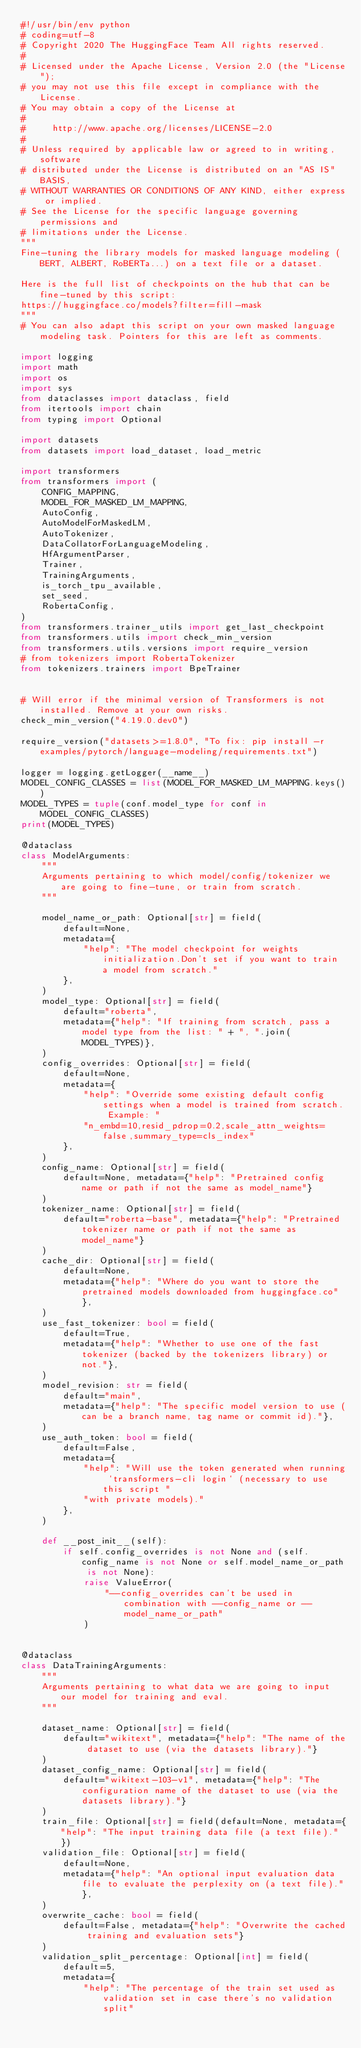Convert code to text. <code><loc_0><loc_0><loc_500><loc_500><_Python_>#!/usr/bin/env python
# coding=utf-8
# Copyright 2020 The HuggingFace Team All rights reserved.
#
# Licensed under the Apache License, Version 2.0 (the "License");
# you may not use this file except in compliance with the License.
# You may obtain a copy of the License at
#
#     http://www.apache.org/licenses/LICENSE-2.0
#
# Unless required by applicable law or agreed to in writing, software
# distributed under the License is distributed on an "AS IS" BASIS,
# WITHOUT WARRANTIES OR CONDITIONS OF ANY KIND, either express or implied.
# See the License for the specific language governing permissions and
# limitations under the License.
"""
Fine-tuning the library models for masked language modeling (BERT, ALBERT, RoBERTa...) on a text file or a dataset.

Here is the full list of checkpoints on the hub that can be fine-tuned by this script:
https://huggingface.co/models?filter=fill-mask
"""
# You can also adapt this script on your own masked language modeling task. Pointers for this are left as comments.

import logging
import math
import os
import sys
from dataclasses import dataclass, field
from itertools import chain
from typing import Optional

import datasets
from datasets import load_dataset, load_metric

import transformers
from transformers import (
    CONFIG_MAPPING,
    MODEL_FOR_MASKED_LM_MAPPING,
    AutoConfig,
    AutoModelForMaskedLM,
    AutoTokenizer,
    DataCollatorForLanguageModeling,
    HfArgumentParser,
    Trainer,
    TrainingArguments,
    is_torch_tpu_available,
    set_seed,
    RobertaConfig,
)
from transformers.trainer_utils import get_last_checkpoint
from transformers.utils import check_min_version
from transformers.utils.versions import require_version
# from tokenizers import RobertaTokenizer
from tokenizers.trainers import BpeTrainer


# Will error if the minimal version of Transformers is not installed. Remove at your own risks.
check_min_version("4.19.0.dev0")

require_version("datasets>=1.8.0", "To fix: pip install -r examples/pytorch/language-modeling/requirements.txt")

logger = logging.getLogger(__name__)
MODEL_CONFIG_CLASSES = list(MODEL_FOR_MASKED_LM_MAPPING.keys())
MODEL_TYPES = tuple(conf.model_type for conf in MODEL_CONFIG_CLASSES)
print(MODEL_TYPES)

@dataclass
class ModelArguments:
    """
    Arguments pertaining to which model/config/tokenizer we are going to fine-tune, or train from scratch.
    """

    model_name_or_path: Optional[str] = field(
        default=None,
        metadata={
            "help": "The model checkpoint for weights initialization.Don't set if you want to train a model from scratch."
        },
    )
    model_type: Optional[str] = field(
        default="roberta",
        metadata={"help": "If training from scratch, pass a model type from the list: " + ", ".join(MODEL_TYPES)},
    )
    config_overrides: Optional[str] = field(
        default=None,
        metadata={
            "help": "Override some existing default config settings when a model is trained from scratch. Example: "
            "n_embd=10,resid_pdrop=0.2,scale_attn_weights=false,summary_type=cls_index"
        },
    )
    config_name: Optional[str] = field(
        default=None, metadata={"help": "Pretrained config name or path if not the same as model_name"}
    )
    tokenizer_name: Optional[str] = field(
        default="roberta-base", metadata={"help": "Pretrained tokenizer name or path if not the same as model_name"}
    )
    cache_dir: Optional[str] = field(
        default=None,
        metadata={"help": "Where do you want to store the pretrained models downloaded from huggingface.co"},
    )
    use_fast_tokenizer: bool = field(
        default=True,
        metadata={"help": "Whether to use one of the fast tokenizer (backed by the tokenizers library) or not."},
    )
    model_revision: str = field(
        default="main",
        metadata={"help": "The specific model version to use (can be a branch name, tag name or commit id)."},
    )
    use_auth_token: bool = field(
        default=False,
        metadata={
            "help": "Will use the token generated when running `transformers-cli login` (necessary to use this script "
            "with private models)."
        },
    )

    def __post_init__(self):
        if self.config_overrides is not None and (self.config_name is not None or self.model_name_or_path is not None):
            raise ValueError(
                "--config_overrides can't be used in combination with --config_name or --model_name_or_path"
            )


@dataclass
class DataTrainingArguments:
    """
    Arguments pertaining to what data we are going to input our model for training and eval.
    """

    dataset_name: Optional[str] = field(
        default="wikitext", metadata={"help": "The name of the dataset to use (via the datasets library)."}
    )
    dataset_config_name: Optional[str] = field(
        default="wikitext-103-v1", metadata={"help": "The configuration name of the dataset to use (via the datasets library)."}
    )
    train_file: Optional[str] = field(default=None, metadata={"help": "The input training data file (a text file)."})
    validation_file: Optional[str] = field(
        default=None,
        metadata={"help": "An optional input evaluation data file to evaluate the perplexity on (a text file)."},
    )
    overwrite_cache: bool = field(
        default=False, metadata={"help": "Overwrite the cached training and evaluation sets"}
    )
    validation_split_percentage: Optional[int] = field(
        default=5,
        metadata={
            "help": "The percentage of the train set used as validation set in case there's no validation split"</code> 